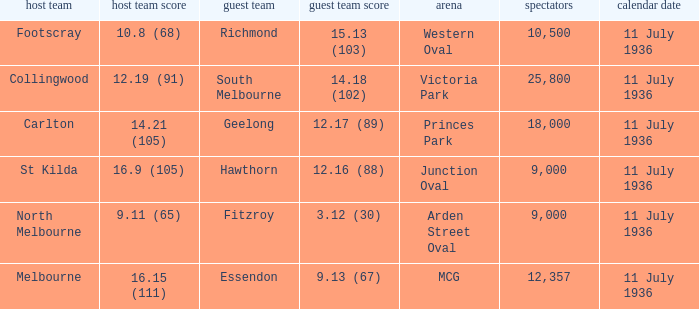When was the game with richmond as Away team? 11 July 1936. 